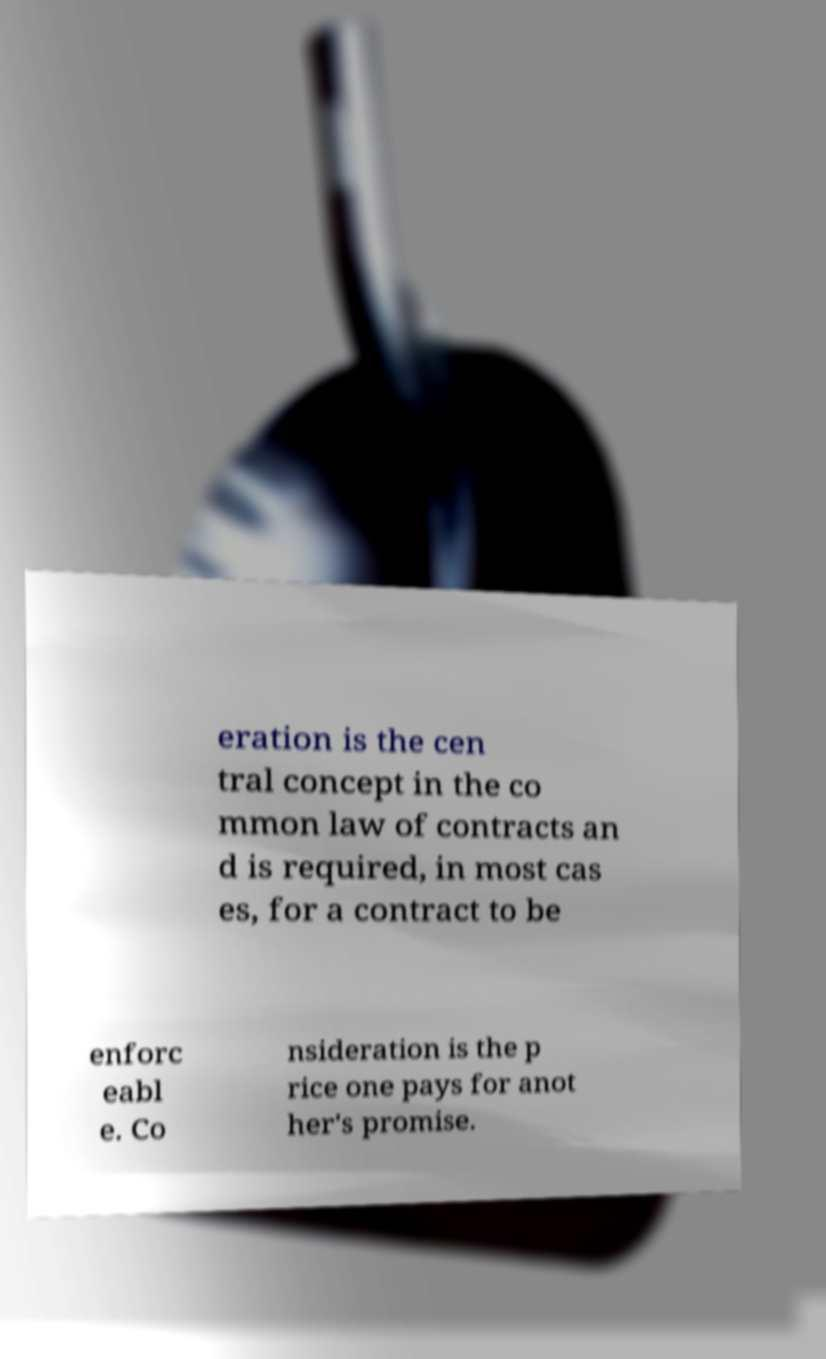Can you accurately transcribe the text from the provided image for me? eration is the cen tral concept in the co mmon law of contracts an d is required, in most cas es, for a contract to be enforc eabl e. Co nsideration is the p rice one pays for anot her's promise. 